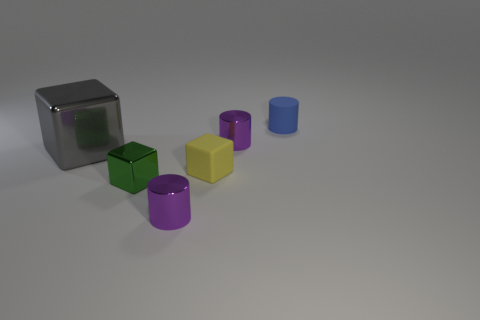Is there any other thing that is the same size as the gray block?
Your answer should be compact. No. What number of gray objects are tiny objects or matte things?
Provide a short and direct response. 0. Is the number of large yellow rubber objects greater than the number of tiny green metal cubes?
Your response must be concise. No. There is a matte object that is on the left side of the matte cylinder; is its size the same as the cylinder in front of the big gray object?
Your answer should be compact. Yes. There is a small cylinder that is to the right of the small purple cylinder behind the purple shiny thing in front of the green block; what is its color?
Ensure brevity in your answer.  Blue. Is there a large red thing of the same shape as the small yellow thing?
Provide a succinct answer. No. Are there more gray cubes on the right side of the yellow cube than brown rubber cylinders?
Ensure brevity in your answer.  No. What number of matte things are either big cyan cylinders or big gray things?
Offer a terse response. 0. How big is the object that is left of the yellow thing and behind the small rubber block?
Make the answer very short. Large. There is a rubber object that is in front of the matte cylinder; are there any big objects to the right of it?
Offer a very short reply. No. 